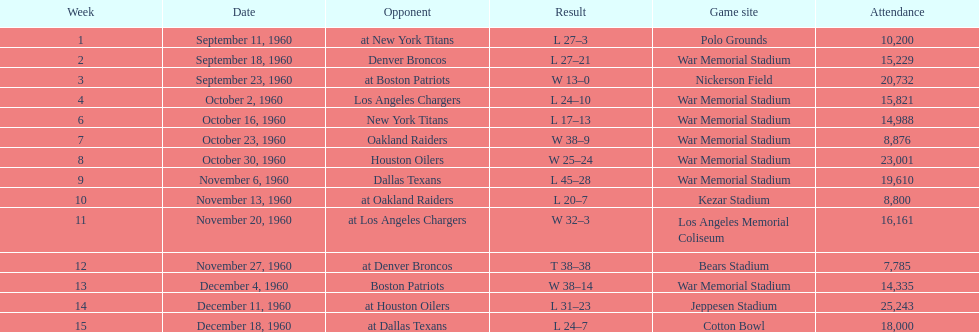How many occasions was war memorial stadium the game venue? 6. 